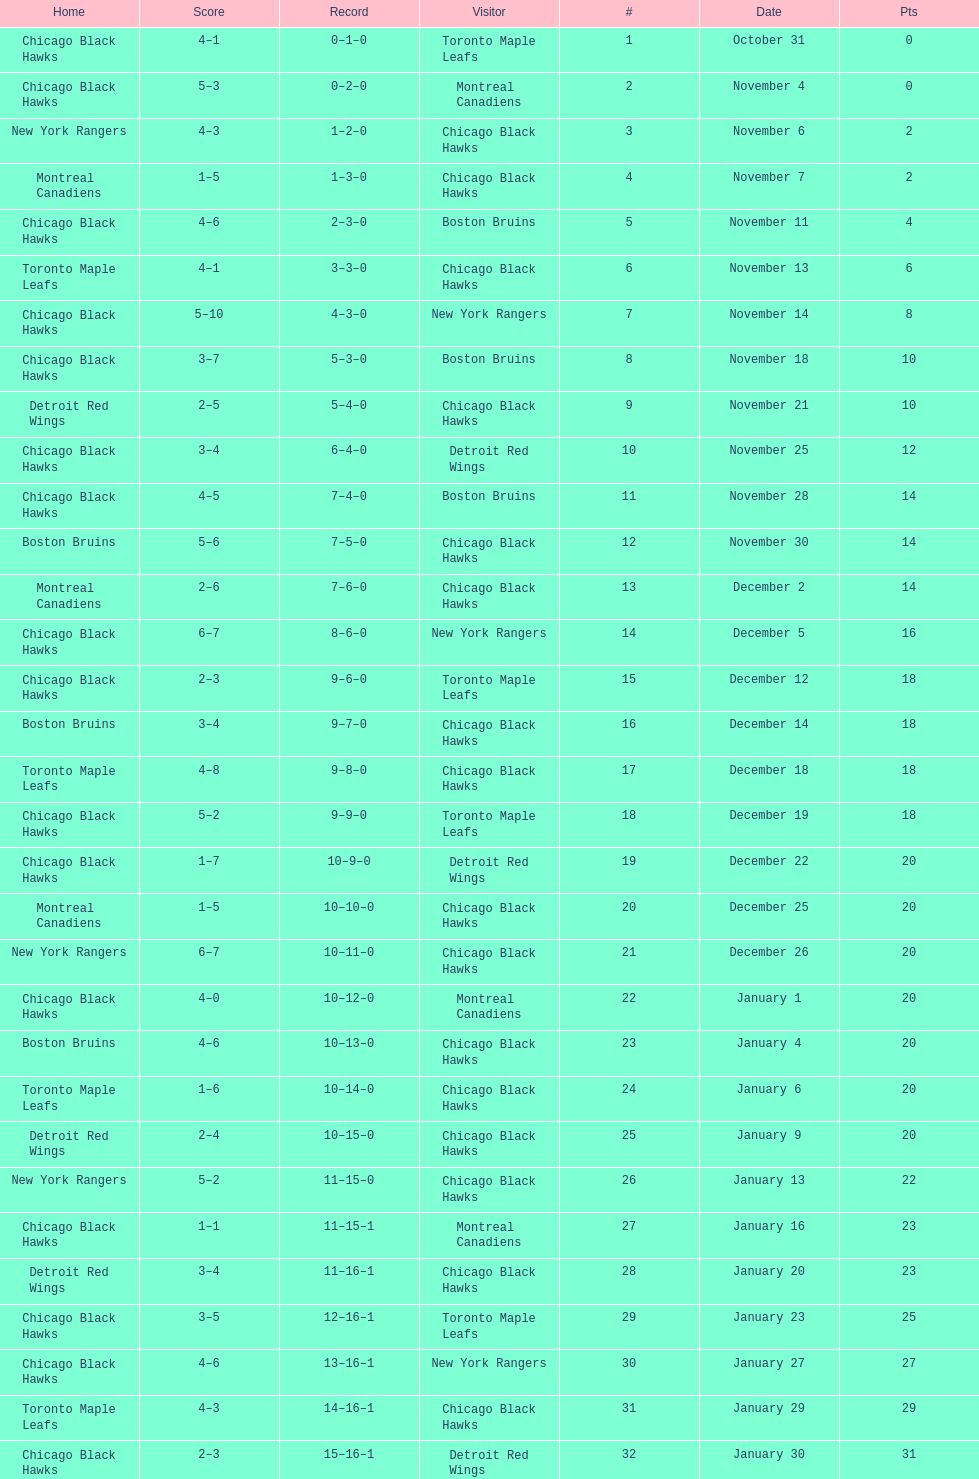On december 14 was the home team the chicago black hawks or the boston bruins? Boston Bruins. 